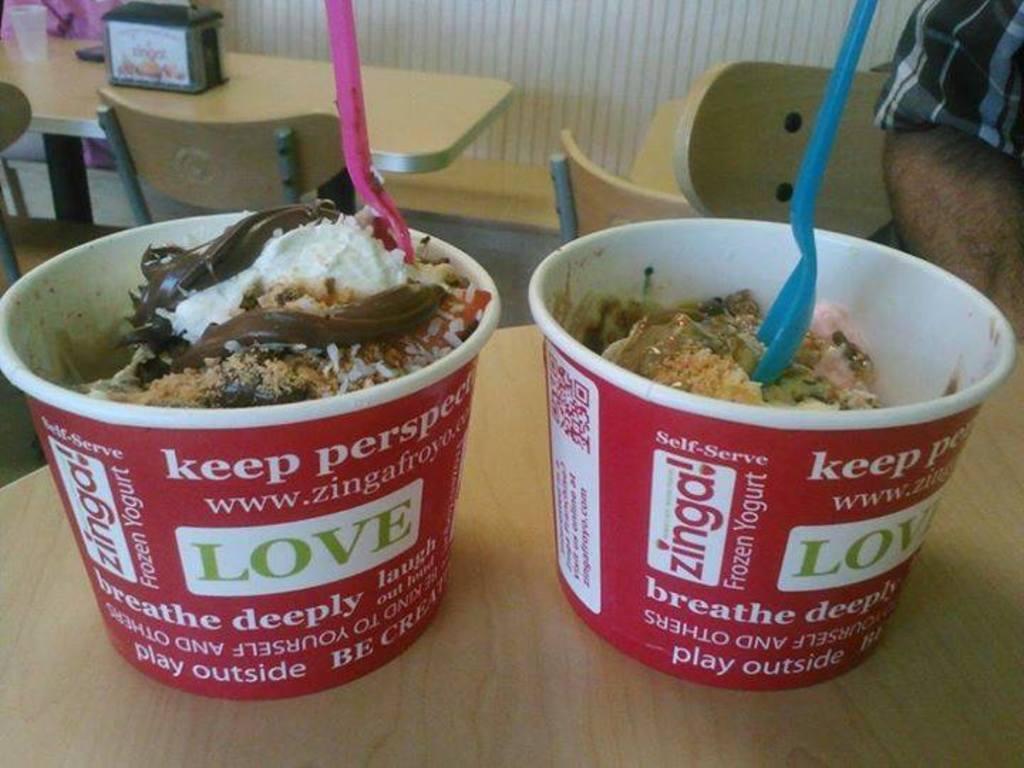Please provide a concise description of this image. In this image we can see dessert places in disposable containers with in them and placed on the table. In the background we can see tables, chairs, tumbler and wall. 